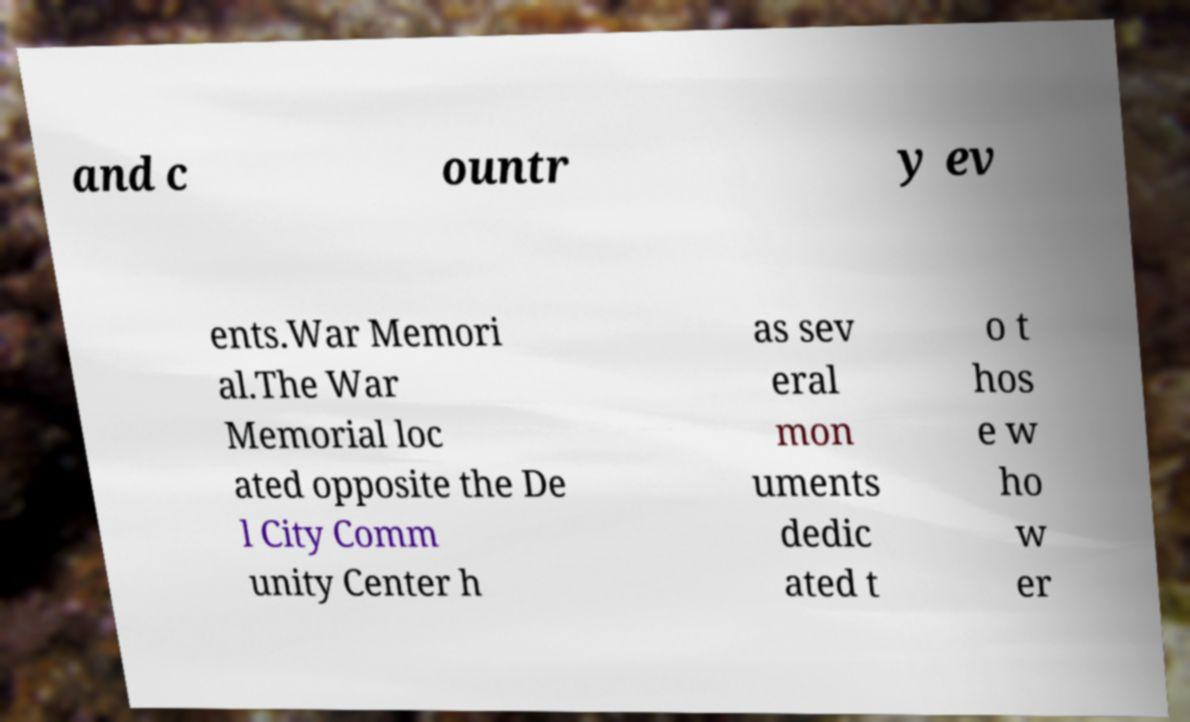Could you assist in decoding the text presented in this image and type it out clearly? and c ountr y ev ents.War Memori al.The War Memorial loc ated opposite the De l City Comm unity Center h as sev eral mon uments dedic ated t o t hos e w ho w er 